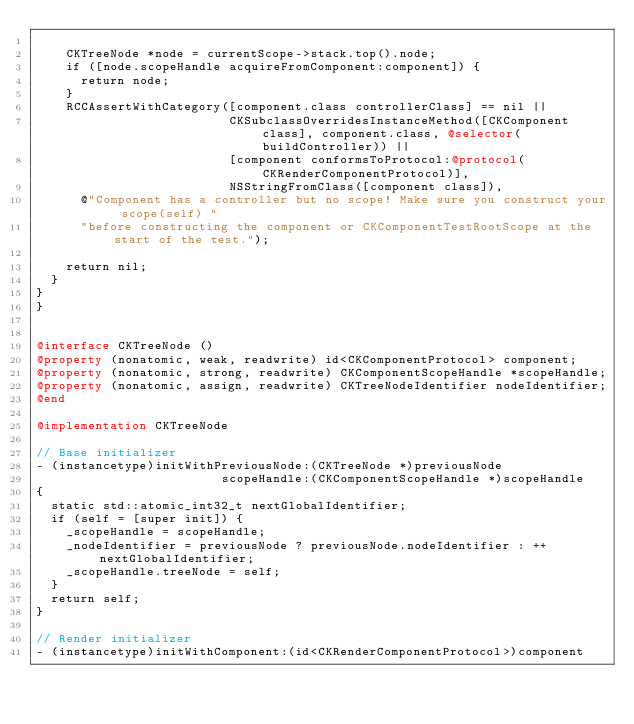Convert code to text. <code><loc_0><loc_0><loc_500><loc_500><_ObjectiveC_>
    CKTreeNode *node = currentScope->stack.top().node;
    if ([node.scopeHandle acquireFromComponent:component]) {
      return node;
    }
    RCCAssertWithCategory([component.class controllerClass] == nil ||
                          CKSubclassOverridesInstanceMethod([CKComponent class], component.class, @selector(buildController)) ||
                          [component conformsToProtocol:@protocol(CKRenderComponentProtocol)],
                          NSStringFromClass([component class]),
      @"Component has a controller but no scope! Make sure you construct your scope(self) "
      "before constructing the component or CKComponentTestRootScope at the start of the test.");

    return nil;
  }
}
}


@interface CKTreeNode ()
@property (nonatomic, weak, readwrite) id<CKComponentProtocol> component;
@property (nonatomic, strong, readwrite) CKComponentScopeHandle *scopeHandle;
@property (nonatomic, assign, readwrite) CKTreeNodeIdentifier nodeIdentifier;
@end

@implementation CKTreeNode

// Base initializer
- (instancetype)initWithPreviousNode:(CKTreeNode *)previousNode
                         scopeHandle:(CKComponentScopeHandle *)scopeHandle
{
  static std::atomic_int32_t nextGlobalIdentifier;
  if (self = [super init]) {
    _scopeHandle = scopeHandle;
    _nodeIdentifier = previousNode ? previousNode.nodeIdentifier : ++nextGlobalIdentifier;
    _scopeHandle.treeNode = self;
  }
  return self;
}

// Render initializer
- (instancetype)initWithComponent:(id<CKRenderComponentProtocol>)component</code> 